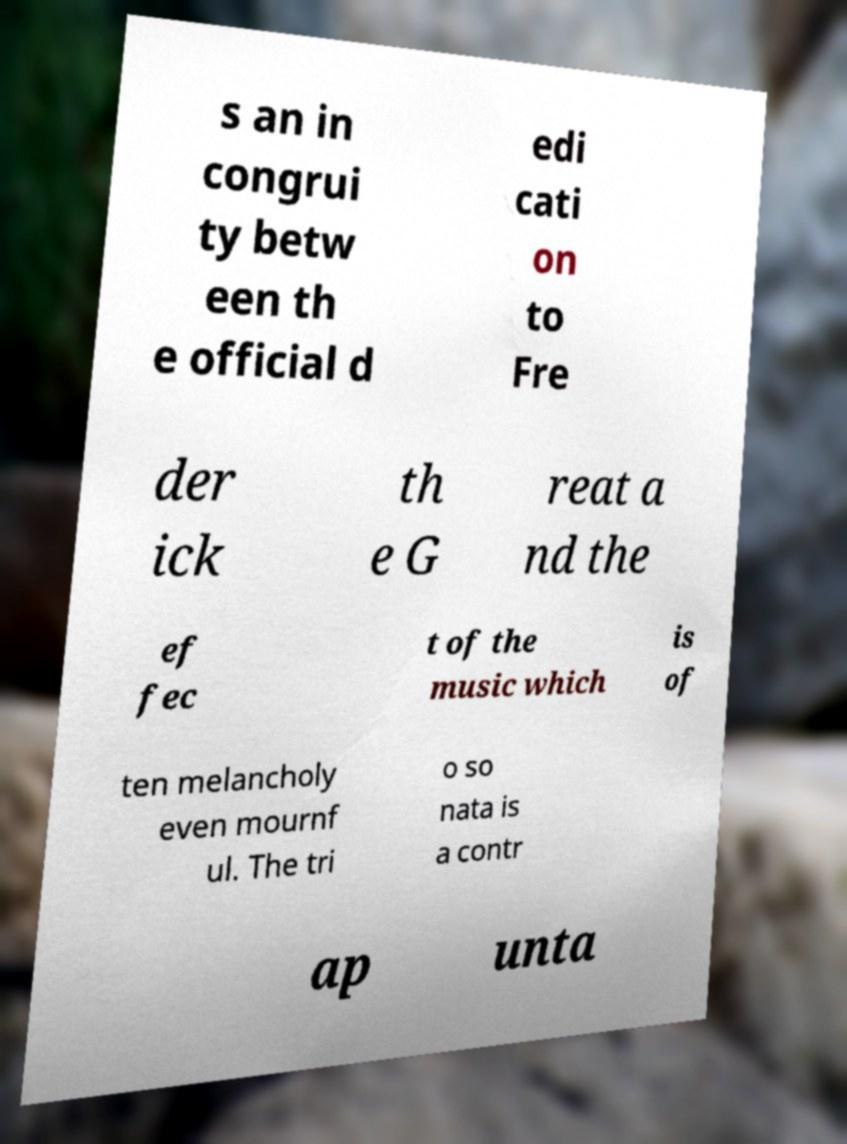Can you accurately transcribe the text from the provided image for me? s an in congrui ty betw een th e official d edi cati on to Fre der ick th e G reat a nd the ef fec t of the music which is of ten melancholy even mournf ul. The tri o so nata is a contr ap unta 